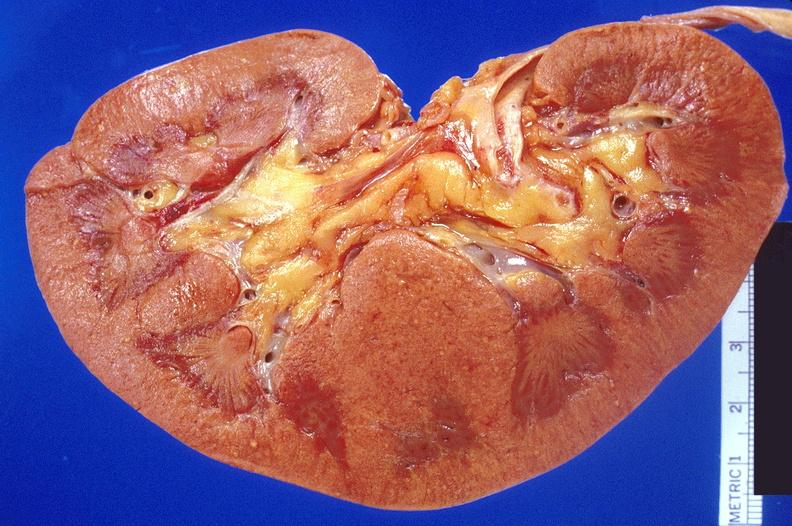what does this image show?
Answer the question using a single word or phrase. Kidney 